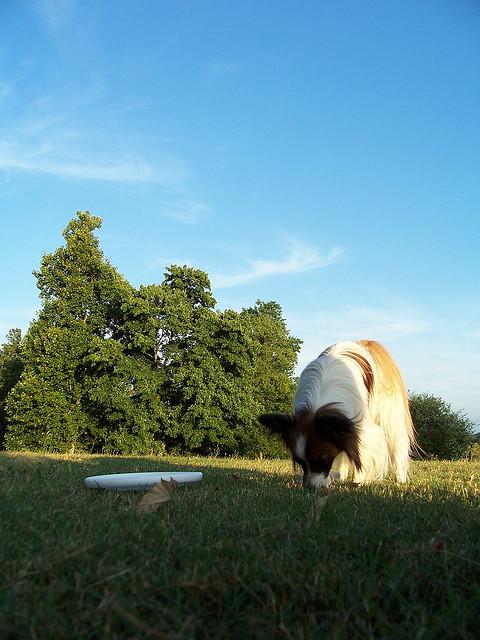What is the white round object on the ground?
Give a very brief answer. Frisbee. What color is the dog's ears?
Concise answer only. Brown. What activity was the dog doing most recently?
Keep it brief. Frisbee. 